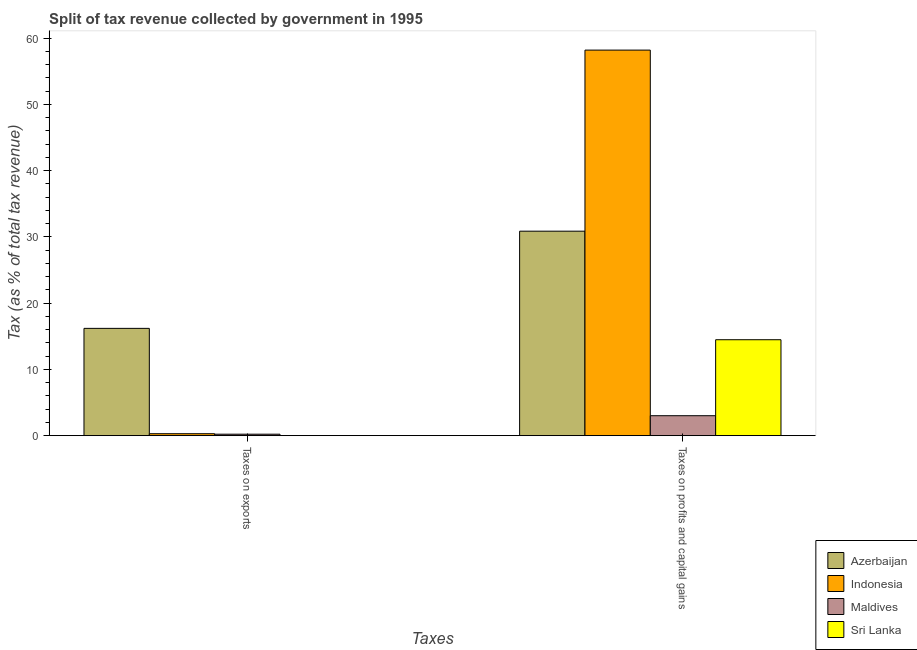How many groups of bars are there?
Provide a short and direct response. 2. Are the number of bars per tick equal to the number of legend labels?
Your response must be concise. Yes. How many bars are there on the 1st tick from the left?
Give a very brief answer. 4. How many bars are there on the 1st tick from the right?
Offer a very short reply. 4. What is the label of the 1st group of bars from the left?
Offer a terse response. Taxes on exports. What is the percentage of revenue obtained from taxes on exports in Sri Lanka?
Make the answer very short. 0.01. Across all countries, what is the maximum percentage of revenue obtained from taxes on exports?
Give a very brief answer. 16.19. Across all countries, what is the minimum percentage of revenue obtained from taxes on profits and capital gains?
Ensure brevity in your answer.  3.01. In which country was the percentage of revenue obtained from taxes on exports minimum?
Make the answer very short. Sri Lanka. What is the total percentage of revenue obtained from taxes on profits and capital gains in the graph?
Your answer should be very brief. 106.53. What is the difference between the percentage of revenue obtained from taxes on profits and capital gains in Sri Lanka and that in Indonesia?
Provide a succinct answer. -43.71. What is the difference between the percentage of revenue obtained from taxes on exports in Maldives and the percentage of revenue obtained from taxes on profits and capital gains in Azerbaijan?
Ensure brevity in your answer.  -30.64. What is the average percentage of revenue obtained from taxes on exports per country?
Offer a terse response. 4.18. What is the difference between the percentage of revenue obtained from taxes on profits and capital gains and percentage of revenue obtained from taxes on exports in Sri Lanka?
Make the answer very short. 14.47. In how many countries, is the percentage of revenue obtained from taxes on profits and capital gains greater than 38 %?
Your answer should be very brief. 1. What is the ratio of the percentage of revenue obtained from taxes on exports in Maldives to that in Sri Lanka?
Keep it short and to the point. 32.49. Is the percentage of revenue obtained from taxes on profits and capital gains in Azerbaijan less than that in Maldives?
Provide a succinct answer. No. What does the 3rd bar from the left in Taxes on exports represents?
Keep it short and to the point. Maldives. What does the 3rd bar from the right in Taxes on exports represents?
Provide a succinct answer. Indonesia. How many bars are there?
Provide a short and direct response. 8. Are all the bars in the graph horizontal?
Give a very brief answer. No. Does the graph contain any zero values?
Provide a short and direct response. No. Does the graph contain grids?
Make the answer very short. No. What is the title of the graph?
Give a very brief answer. Split of tax revenue collected by government in 1995. What is the label or title of the X-axis?
Provide a short and direct response. Taxes. What is the label or title of the Y-axis?
Offer a terse response. Tax (as % of total tax revenue). What is the Tax (as % of total tax revenue) of Azerbaijan in Taxes on exports?
Keep it short and to the point. 16.19. What is the Tax (as % of total tax revenue) in Indonesia in Taxes on exports?
Offer a very short reply. 0.29. What is the Tax (as % of total tax revenue) of Maldives in Taxes on exports?
Offer a terse response. 0.22. What is the Tax (as % of total tax revenue) in Sri Lanka in Taxes on exports?
Ensure brevity in your answer.  0.01. What is the Tax (as % of total tax revenue) in Azerbaijan in Taxes on profits and capital gains?
Make the answer very short. 30.86. What is the Tax (as % of total tax revenue) in Indonesia in Taxes on profits and capital gains?
Your response must be concise. 58.19. What is the Tax (as % of total tax revenue) of Maldives in Taxes on profits and capital gains?
Ensure brevity in your answer.  3.01. What is the Tax (as % of total tax revenue) in Sri Lanka in Taxes on profits and capital gains?
Make the answer very short. 14.48. Across all Taxes, what is the maximum Tax (as % of total tax revenue) in Azerbaijan?
Give a very brief answer. 30.86. Across all Taxes, what is the maximum Tax (as % of total tax revenue) of Indonesia?
Ensure brevity in your answer.  58.19. Across all Taxes, what is the maximum Tax (as % of total tax revenue) in Maldives?
Make the answer very short. 3.01. Across all Taxes, what is the maximum Tax (as % of total tax revenue) of Sri Lanka?
Make the answer very short. 14.48. Across all Taxes, what is the minimum Tax (as % of total tax revenue) of Azerbaijan?
Your answer should be compact. 16.19. Across all Taxes, what is the minimum Tax (as % of total tax revenue) in Indonesia?
Make the answer very short. 0.29. Across all Taxes, what is the minimum Tax (as % of total tax revenue) of Maldives?
Your answer should be compact. 0.22. Across all Taxes, what is the minimum Tax (as % of total tax revenue) in Sri Lanka?
Ensure brevity in your answer.  0.01. What is the total Tax (as % of total tax revenue) in Azerbaijan in the graph?
Your response must be concise. 47.05. What is the total Tax (as % of total tax revenue) of Indonesia in the graph?
Keep it short and to the point. 58.48. What is the total Tax (as % of total tax revenue) in Maldives in the graph?
Your response must be concise. 3.23. What is the total Tax (as % of total tax revenue) in Sri Lanka in the graph?
Your answer should be compact. 14.48. What is the difference between the Tax (as % of total tax revenue) of Azerbaijan in Taxes on exports and that in Taxes on profits and capital gains?
Your answer should be compact. -14.67. What is the difference between the Tax (as % of total tax revenue) of Indonesia in Taxes on exports and that in Taxes on profits and capital gains?
Ensure brevity in your answer.  -57.89. What is the difference between the Tax (as % of total tax revenue) in Maldives in Taxes on exports and that in Taxes on profits and capital gains?
Ensure brevity in your answer.  -2.79. What is the difference between the Tax (as % of total tax revenue) in Sri Lanka in Taxes on exports and that in Taxes on profits and capital gains?
Make the answer very short. -14.47. What is the difference between the Tax (as % of total tax revenue) of Azerbaijan in Taxes on exports and the Tax (as % of total tax revenue) of Indonesia in Taxes on profits and capital gains?
Provide a short and direct response. -42. What is the difference between the Tax (as % of total tax revenue) in Azerbaijan in Taxes on exports and the Tax (as % of total tax revenue) in Maldives in Taxes on profits and capital gains?
Offer a very short reply. 13.18. What is the difference between the Tax (as % of total tax revenue) of Azerbaijan in Taxes on exports and the Tax (as % of total tax revenue) of Sri Lanka in Taxes on profits and capital gains?
Provide a short and direct response. 1.71. What is the difference between the Tax (as % of total tax revenue) in Indonesia in Taxes on exports and the Tax (as % of total tax revenue) in Maldives in Taxes on profits and capital gains?
Keep it short and to the point. -2.72. What is the difference between the Tax (as % of total tax revenue) of Indonesia in Taxes on exports and the Tax (as % of total tax revenue) of Sri Lanka in Taxes on profits and capital gains?
Your answer should be compact. -14.18. What is the difference between the Tax (as % of total tax revenue) of Maldives in Taxes on exports and the Tax (as % of total tax revenue) of Sri Lanka in Taxes on profits and capital gains?
Offer a terse response. -14.26. What is the average Tax (as % of total tax revenue) of Azerbaijan per Taxes?
Your response must be concise. 23.52. What is the average Tax (as % of total tax revenue) in Indonesia per Taxes?
Keep it short and to the point. 29.24. What is the average Tax (as % of total tax revenue) of Maldives per Taxes?
Offer a terse response. 1.61. What is the average Tax (as % of total tax revenue) of Sri Lanka per Taxes?
Ensure brevity in your answer.  7.24. What is the difference between the Tax (as % of total tax revenue) of Azerbaijan and Tax (as % of total tax revenue) of Indonesia in Taxes on exports?
Ensure brevity in your answer.  15.9. What is the difference between the Tax (as % of total tax revenue) of Azerbaijan and Tax (as % of total tax revenue) of Maldives in Taxes on exports?
Your answer should be very brief. 15.97. What is the difference between the Tax (as % of total tax revenue) of Azerbaijan and Tax (as % of total tax revenue) of Sri Lanka in Taxes on exports?
Ensure brevity in your answer.  16.18. What is the difference between the Tax (as % of total tax revenue) in Indonesia and Tax (as % of total tax revenue) in Maldives in Taxes on exports?
Your answer should be very brief. 0.07. What is the difference between the Tax (as % of total tax revenue) of Indonesia and Tax (as % of total tax revenue) of Sri Lanka in Taxes on exports?
Provide a short and direct response. 0.29. What is the difference between the Tax (as % of total tax revenue) of Maldives and Tax (as % of total tax revenue) of Sri Lanka in Taxes on exports?
Your answer should be very brief. 0.21. What is the difference between the Tax (as % of total tax revenue) in Azerbaijan and Tax (as % of total tax revenue) in Indonesia in Taxes on profits and capital gains?
Your response must be concise. -27.33. What is the difference between the Tax (as % of total tax revenue) in Azerbaijan and Tax (as % of total tax revenue) in Maldives in Taxes on profits and capital gains?
Offer a very short reply. 27.85. What is the difference between the Tax (as % of total tax revenue) in Azerbaijan and Tax (as % of total tax revenue) in Sri Lanka in Taxes on profits and capital gains?
Provide a short and direct response. 16.38. What is the difference between the Tax (as % of total tax revenue) of Indonesia and Tax (as % of total tax revenue) of Maldives in Taxes on profits and capital gains?
Your answer should be very brief. 55.18. What is the difference between the Tax (as % of total tax revenue) of Indonesia and Tax (as % of total tax revenue) of Sri Lanka in Taxes on profits and capital gains?
Make the answer very short. 43.71. What is the difference between the Tax (as % of total tax revenue) in Maldives and Tax (as % of total tax revenue) in Sri Lanka in Taxes on profits and capital gains?
Keep it short and to the point. -11.47. What is the ratio of the Tax (as % of total tax revenue) of Azerbaijan in Taxes on exports to that in Taxes on profits and capital gains?
Make the answer very short. 0.52. What is the ratio of the Tax (as % of total tax revenue) of Indonesia in Taxes on exports to that in Taxes on profits and capital gains?
Make the answer very short. 0.01. What is the ratio of the Tax (as % of total tax revenue) of Maldives in Taxes on exports to that in Taxes on profits and capital gains?
Ensure brevity in your answer.  0.07. What is the difference between the highest and the second highest Tax (as % of total tax revenue) of Azerbaijan?
Provide a short and direct response. 14.67. What is the difference between the highest and the second highest Tax (as % of total tax revenue) in Indonesia?
Your answer should be compact. 57.89. What is the difference between the highest and the second highest Tax (as % of total tax revenue) of Maldives?
Your answer should be very brief. 2.79. What is the difference between the highest and the second highest Tax (as % of total tax revenue) of Sri Lanka?
Your answer should be compact. 14.47. What is the difference between the highest and the lowest Tax (as % of total tax revenue) of Azerbaijan?
Keep it short and to the point. 14.67. What is the difference between the highest and the lowest Tax (as % of total tax revenue) in Indonesia?
Provide a succinct answer. 57.89. What is the difference between the highest and the lowest Tax (as % of total tax revenue) in Maldives?
Provide a short and direct response. 2.79. What is the difference between the highest and the lowest Tax (as % of total tax revenue) in Sri Lanka?
Give a very brief answer. 14.47. 